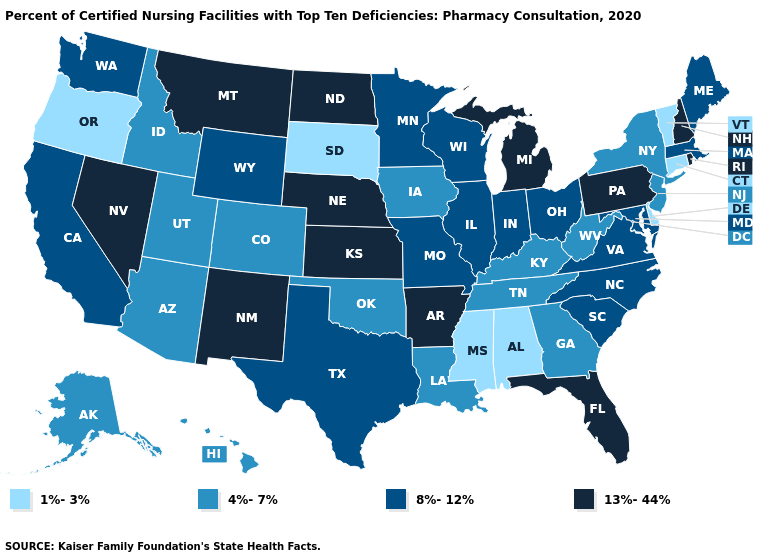Does Michigan have the highest value in the USA?
Write a very short answer. Yes. Does Connecticut have the lowest value in the USA?
Be succinct. Yes. Does the first symbol in the legend represent the smallest category?
Keep it brief. Yes. What is the value of Minnesota?
Answer briefly. 8%-12%. Name the states that have a value in the range 4%-7%?
Give a very brief answer. Alaska, Arizona, Colorado, Georgia, Hawaii, Idaho, Iowa, Kentucky, Louisiana, New Jersey, New York, Oklahoma, Tennessee, Utah, West Virginia. Name the states that have a value in the range 13%-44%?
Give a very brief answer. Arkansas, Florida, Kansas, Michigan, Montana, Nebraska, Nevada, New Hampshire, New Mexico, North Dakota, Pennsylvania, Rhode Island. How many symbols are there in the legend?
Quick response, please. 4. What is the value of Florida?
Short answer required. 13%-44%. Does Colorado have the same value as Massachusetts?
Short answer required. No. Does Maine have a higher value than Mississippi?
Answer briefly. Yes. Name the states that have a value in the range 8%-12%?
Quick response, please. California, Illinois, Indiana, Maine, Maryland, Massachusetts, Minnesota, Missouri, North Carolina, Ohio, South Carolina, Texas, Virginia, Washington, Wisconsin, Wyoming. Name the states that have a value in the range 13%-44%?
Quick response, please. Arkansas, Florida, Kansas, Michigan, Montana, Nebraska, Nevada, New Hampshire, New Mexico, North Dakota, Pennsylvania, Rhode Island. Name the states that have a value in the range 1%-3%?
Keep it brief. Alabama, Connecticut, Delaware, Mississippi, Oregon, South Dakota, Vermont. Which states have the highest value in the USA?
Quick response, please. Arkansas, Florida, Kansas, Michigan, Montana, Nebraska, Nevada, New Hampshire, New Mexico, North Dakota, Pennsylvania, Rhode Island. What is the lowest value in the USA?
Be succinct. 1%-3%. 